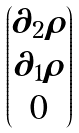Convert formula to latex. <formula><loc_0><loc_0><loc_500><loc_500>\begin{pmatrix} \partial _ { 2 } \rho \\ \partial _ { 1 } \rho \\ 0 \end{pmatrix}</formula> 